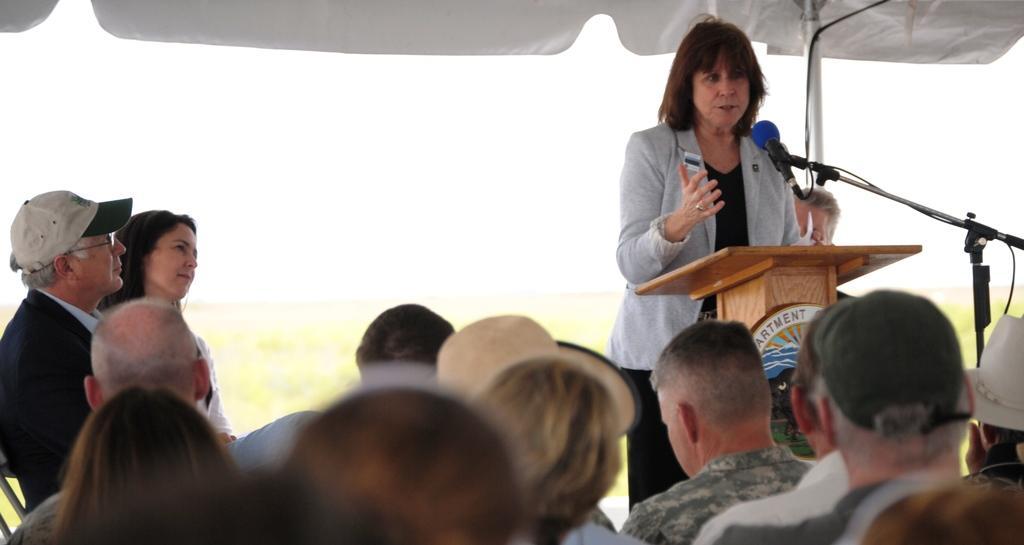Please provide a concise description of this image. In this image there are people sitting on chairs, in front of them there is a woman standing near a podium and there is a mike, in the background it is blurred. 